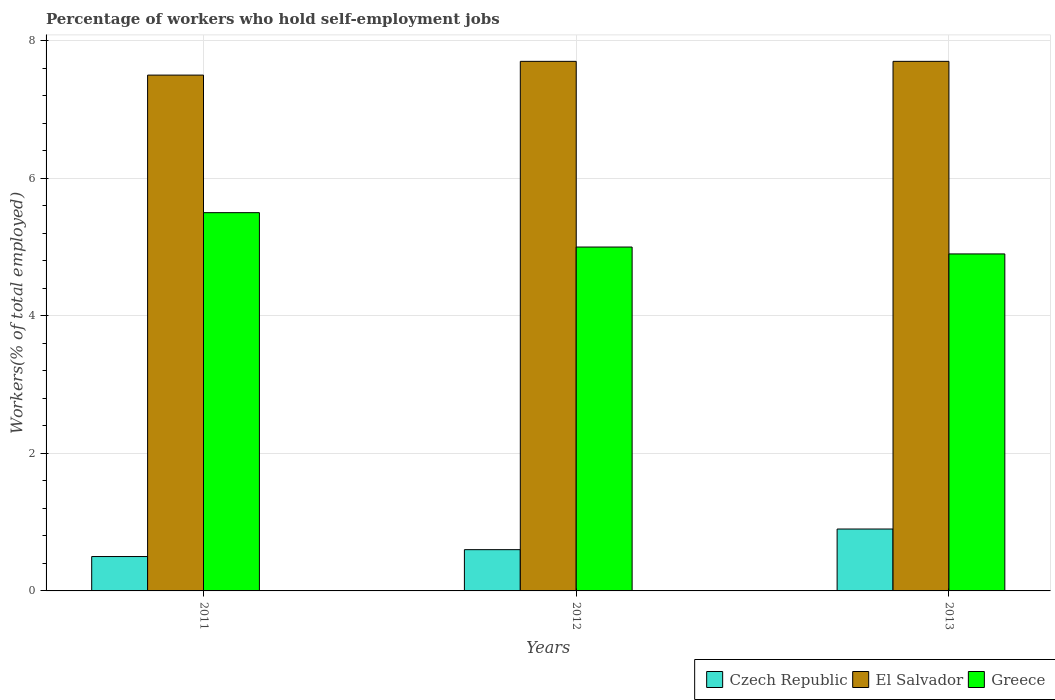How many groups of bars are there?
Make the answer very short. 3. Are the number of bars on each tick of the X-axis equal?
Your answer should be very brief. Yes. How many bars are there on the 1st tick from the left?
Ensure brevity in your answer.  3. What is the percentage of self-employed workers in Czech Republic in 2013?
Ensure brevity in your answer.  0.9. Across all years, what is the maximum percentage of self-employed workers in Czech Republic?
Ensure brevity in your answer.  0.9. In which year was the percentage of self-employed workers in Czech Republic maximum?
Your answer should be very brief. 2013. What is the total percentage of self-employed workers in El Salvador in the graph?
Ensure brevity in your answer.  22.9. What is the difference between the percentage of self-employed workers in Greece in 2011 and that in 2013?
Ensure brevity in your answer.  0.6. What is the difference between the percentage of self-employed workers in Czech Republic in 2011 and the percentage of self-employed workers in Greece in 2013?
Offer a very short reply. -4.4. What is the average percentage of self-employed workers in El Salvador per year?
Keep it short and to the point. 7.63. In the year 2013, what is the difference between the percentage of self-employed workers in Czech Republic and percentage of self-employed workers in El Salvador?
Keep it short and to the point. -6.8. Is the percentage of self-employed workers in Czech Republic in 2012 less than that in 2013?
Your answer should be compact. Yes. Is the difference between the percentage of self-employed workers in Czech Republic in 2012 and 2013 greater than the difference between the percentage of self-employed workers in El Salvador in 2012 and 2013?
Provide a short and direct response. No. What is the difference between the highest and the second highest percentage of self-employed workers in Czech Republic?
Keep it short and to the point. 0.3. What is the difference between the highest and the lowest percentage of self-employed workers in Greece?
Offer a terse response. 0.6. In how many years, is the percentage of self-employed workers in El Salvador greater than the average percentage of self-employed workers in El Salvador taken over all years?
Your answer should be very brief. 2. Is the sum of the percentage of self-employed workers in Greece in 2011 and 2012 greater than the maximum percentage of self-employed workers in Czech Republic across all years?
Ensure brevity in your answer.  Yes. What does the 1st bar from the left in 2012 represents?
Offer a very short reply. Czech Republic. What does the 2nd bar from the right in 2011 represents?
Give a very brief answer. El Salvador. Is it the case that in every year, the sum of the percentage of self-employed workers in El Salvador and percentage of self-employed workers in Czech Republic is greater than the percentage of self-employed workers in Greece?
Make the answer very short. Yes. How many bars are there?
Make the answer very short. 9. What is the difference between two consecutive major ticks on the Y-axis?
Make the answer very short. 2. Does the graph contain any zero values?
Provide a short and direct response. No. Does the graph contain grids?
Give a very brief answer. Yes. Where does the legend appear in the graph?
Your answer should be very brief. Bottom right. How many legend labels are there?
Provide a short and direct response. 3. How are the legend labels stacked?
Provide a short and direct response. Horizontal. What is the title of the graph?
Provide a short and direct response. Percentage of workers who hold self-employment jobs. What is the label or title of the X-axis?
Keep it short and to the point. Years. What is the label or title of the Y-axis?
Keep it short and to the point. Workers(% of total employed). What is the Workers(% of total employed) of Czech Republic in 2011?
Provide a succinct answer. 0.5. What is the Workers(% of total employed) in Greece in 2011?
Your answer should be compact. 5.5. What is the Workers(% of total employed) of Czech Republic in 2012?
Offer a terse response. 0.6. What is the Workers(% of total employed) of El Salvador in 2012?
Provide a succinct answer. 7.7. What is the Workers(% of total employed) of Greece in 2012?
Provide a short and direct response. 5. What is the Workers(% of total employed) of Czech Republic in 2013?
Offer a terse response. 0.9. What is the Workers(% of total employed) of El Salvador in 2013?
Offer a terse response. 7.7. What is the Workers(% of total employed) in Greece in 2013?
Your answer should be very brief. 4.9. Across all years, what is the maximum Workers(% of total employed) in Czech Republic?
Ensure brevity in your answer.  0.9. Across all years, what is the maximum Workers(% of total employed) in El Salvador?
Offer a very short reply. 7.7. Across all years, what is the minimum Workers(% of total employed) of El Salvador?
Ensure brevity in your answer.  7.5. Across all years, what is the minimum Workers(% of total employed) in Greece?
Your answer should be very brief. 4.9. What is the total Workers(% of total employed) in Czech Republic in the graph?
Offer a terse response. 2. What is the total Workers(% of total employed) in El Salvador in the graph?
Your answer should be compact. 22.9. What is the difference between the Workers(% of total employed) of Czech Republic in 2011 and that in 2012?
Offer a terse response. -0.1. What is the difference between the Workers(% of total employed) in Greece in 2011 and that in 2012?
Your answer should be very brief. 0.5. What is the difference between the Workers(% of total employed) in Czech Republic in 2011 and that in 2013?
Provide a short and direct response. -0.4. What is the difference between the Workers(% of total employed) in El Salvador in 2011 and that in 2013?
Your response must be concise. -0.2. What is the difference between the Workers(% of total employed) of Greece in 2011 and that in 2013?
Your response must be concise. 0.6. What is the difference between the Workers(% of total employed) in Czech Republic in 2012 and that in 2013?
Offer a very short reply. -0.3. What is the difference between the Workers(% of total employed) of El Salvador in 2012 and that in 2013?
Ensure brevity in your answer.  0. What is the difference between the Workers(% of total employed) in Greece in 2012 and that in 2013?
Make the answer very short. 0.1. What is the difference between the Workers(% of total employed) of Czech Republic in 2011 and the Workers(% of total employed) of El Salvador in 2012?
Provide a short and direct response. -7.2. What is the difference between the Workers(% of total employed) of Czech Republic in 2011 and the Workers(% of total employed) of Greece in 2012?
Provide a succinct answer. -4.5. What is the difference between the Workers(% of total employed) of El Salvador in 2011 and the Workers(% of total employed) of Greece in 2012?
Your answer should be compact. 2.5. What is the difference between the Workers(% of total employed) of Czech Republic in 2011 and the Workers(% of total employed) of El Salvador in 2013?
Your answer should be very brief. -7.2. What is the difference between the Workers(% of total employed) of Czech Republic in 2011 and the Workers(% of total employed) of Greece in 2013?
Give a very brief answer. -4.4. What is the difference between the Workers(% of total employed) in Czech Republic in 2012 and the Workers(% of total employed) in El Salvador in 2013?
Your response must be concise. -7.1. What is the difference between the Workers(% of total employed) in El Salvador in 2012 and the Workers(% of total employed) in Greece in 2013?
Provide a short and direct response. 2.8. What is the average Workers(% of total employed) in El Salvador per year?
Your answer should be compact. 7.63. What is the average Workers(% of total employed) of Greece per year?
Provide a short and direct response. 5.13. In the year 2011, what is the difference between the Workers(% of total employed) in Czech Republic and Workers(% of total employed) in El Salvador?
Your response must be concise. -7. In the year 2012, what is the difference between the Workers(% of total employed) of El Salvador and Workers(% of total employed) of Greece?
Offer a very short reply. 2.7. What is the ratio of the Workers(% of total employed) in El Salvador in 2011 to that in 2012?
Your answer should be very brief. 0.97. What is the ratio of the Workers(% of total employed) in Czech Republic in 2011 to that in 2013?
Give a very brief answer. 0.56. What is the ratio of the Workers(% of total employed) in Greece in 2011 to that in 2013?
Give a very brief answer. 1.12. What is the ratio of the Workers(% of total employed) of Greece in 2012 to that in 2013?
Ensure brevity in your answer.  1.02. What is the difference between the highest and the second highest Workers(% of total employed) of Czech Republic?
Provide a succinct answer. 0.3. What is the difference between the highest and the second highest Workers(% of total employed) in Greece?
Ensure brevity in your answer.  0.5. What is the difference between the highest and the lowest Workers(% of total employed) in Czech Republic?
Provide a short and direct response. 0.4. What is the difference between the highest and the lowest Workers(% of total employed) in El Salvador?
Your response must be concise. 0.2. 